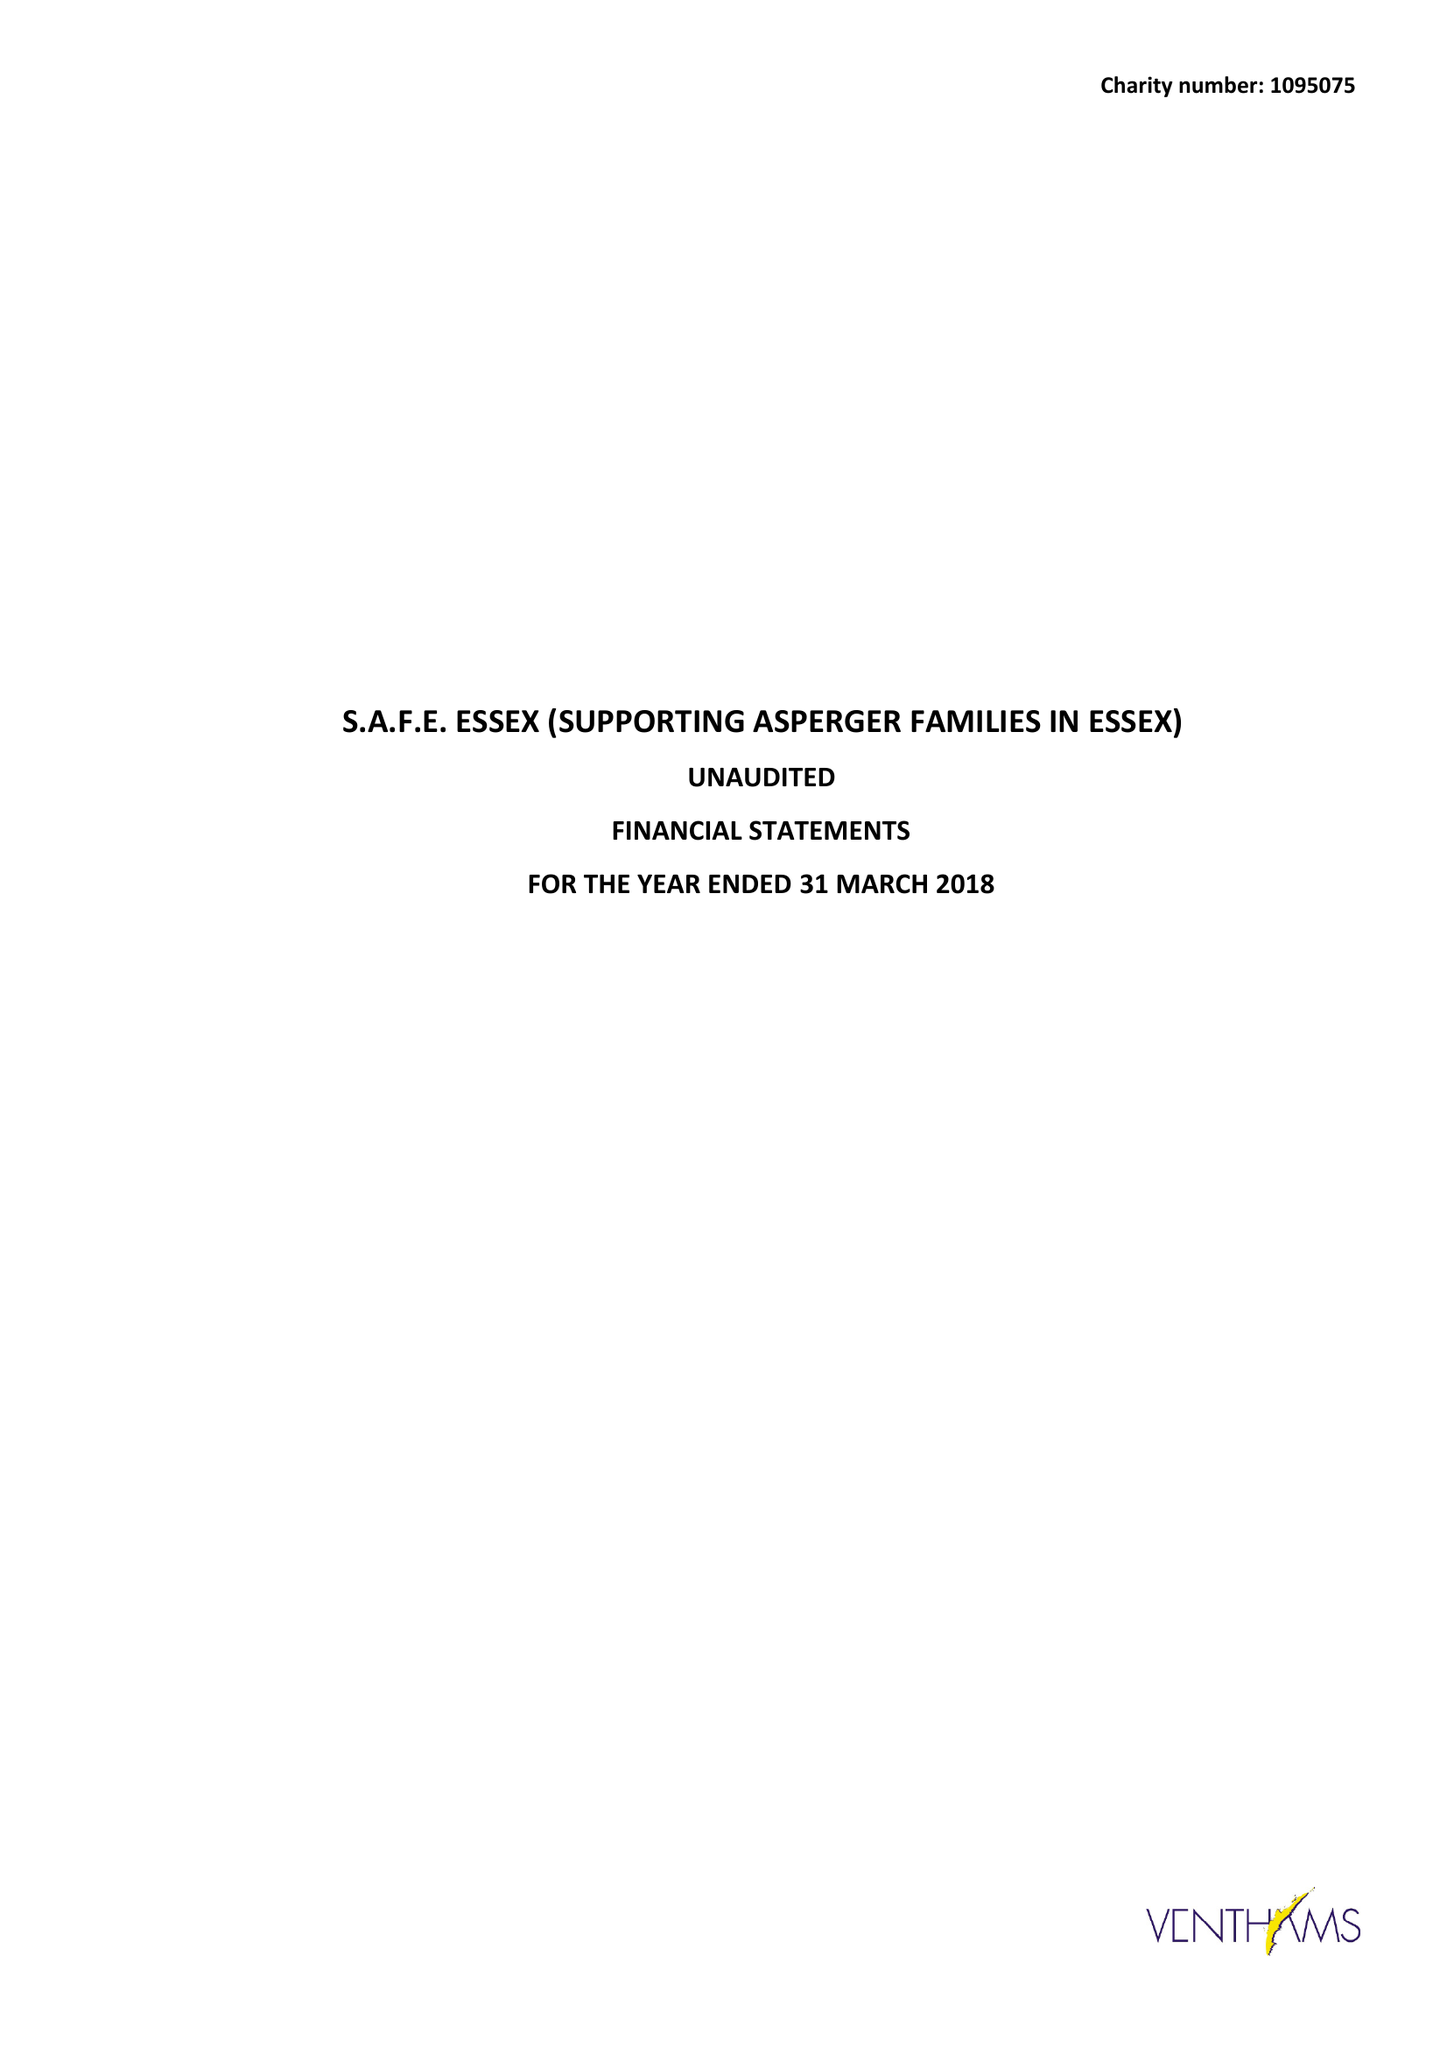What is the value for the charity_name?
Answer the question using a single word or phrase. S.A.F.E. Essex (Supporting Asperger Families In Essex) 